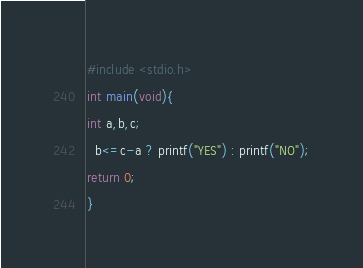<code> <loc_0><loc_0><loc_500><loc_500><_C_>#include <stdio.h>
int main(void){
int a,b,c;
  b<=c-a ? printf("YES") : printf("NO");
return 0;
}</code> 